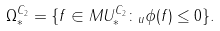Convert formula to latex. <formula><loc_0><loc_0><loc_500><loc_500>\Omega ^ { C _ { 2 } } _ { * } = \{ f \in M U ^ { C _ { 2 } } _ { * } \colon _ { u } \phi ( f ) \leq 0 \} .</formula> 